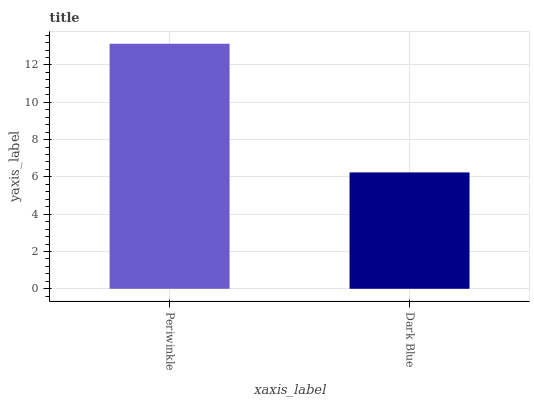Is Dark Blue the minimum?
Answer yes or no. Yes. Is Periwinkle the maximum?
Answer yes or no. Yes. Is Dark Blue the maximum?
Answer yes or no. No. Is Periwinkle greater than Dark Blue?
Answer yes or no. Yes. Is Dark Blue less than Periwinkle?
Answer yes or no. Yes. Is Dark Blue greater than Periwinkle?
Answer yes or no. No. Is Periwinkle less than Dark Blue?
Answer yes or no. No. Is Periwinkle the high median?
Answer yes or no. Yes. Is Dark Blue the low median?
Answer yes or no. Yes. Is Dark Blue the high median?
Answer yes or no. No. Is Periwinkle the low median?
Answer yes or no. No. 